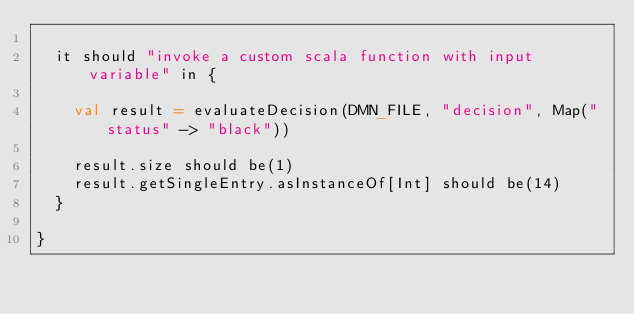<code> <loc_0><loc_0><loc_500><loc_500><_Scala_>  
  it should "invoke a custom scala function with input variable" in {

    val result = evaluateDecision(DMN_FILE, "decision", Map("status" -> "black"))

    result.size should be(1)
    result.getSingleEntry.asInstanceOf[Int] should be(14)
  }
  
}</code> 